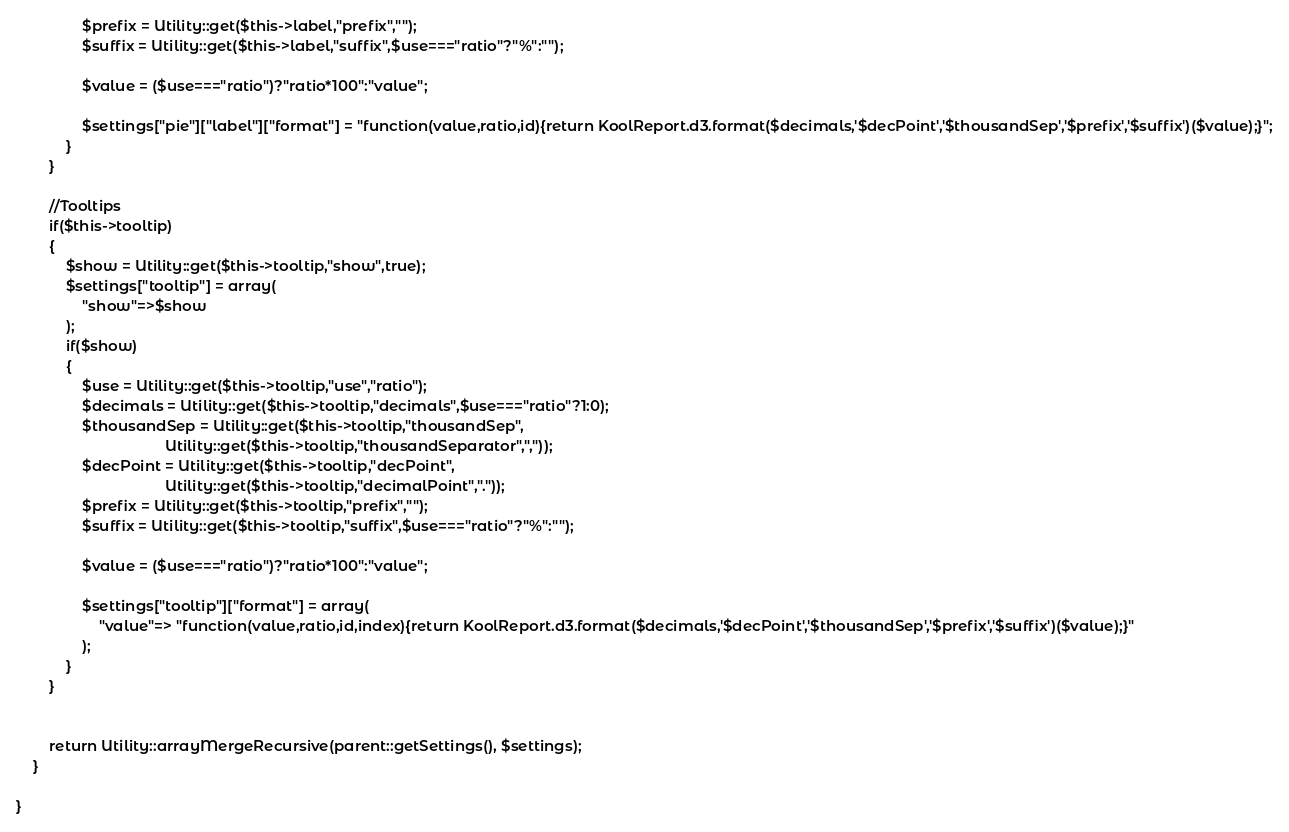<code> <loc_0><loc_0><loc_500><loc_500><_PHP_>                $prefix = Utility::get($this->label,"prefix","");
                $suffix = Utility::get($this->label,"suffix",$use==="ratio"?"%":"");

                $value = ($use==="ratio")?"ratio*100":"value";

                $settings["pie"]["label"]["format"] = "function(value,ratio,id){return KoolReport.d3.format($decimals,'$decPoint','$thousandSep','$prefix','$suffix')($value);}";
            }
        }

        //Tooltips
        if($this->tooltip)
        {
            $show = Utility::get($this->tooltip,"show",true);
            $settings["tooltip"] = array(
                "show"=>$show
            );
            if($show)
            {
                $use = Utility::get($this->tooltip,"use","ratio");
                $decimals = Utility::get($this->tooltip,"decimals",$use==="ratio"?1:0);
                $thousandSep = Utility::get($this->tooltip,"thousandSep",
                                    Utility::get($this->tooltip,"thousandSeparator",","));
                $decPoint = Utility::get($this->tooltip,"decPoint",
                                    Utility::get($this->tooltip,"decimalPoint","."));    
                $prefix = Utility::get($this->tooltip,"prefix","");
                $suffix = Utility::get($this->tooltip,"suffix",$use==="ratio"?"%":"");
    
                $value = ($use==="ratio")?"ratio*100":"value";
    
                $settings["tooltip"]["format"] = array(
                    "value"=> "function(value,ratio,id,index){return KoolReport.d3.format($decimals,'$decPoint','$thousandSep','$prefix','$suffix')($value);}"
                );    
            } 
        }


        return Utility::arrayMergeRecursive(parent::getSettings(), $settings);
    }

}
</code> 